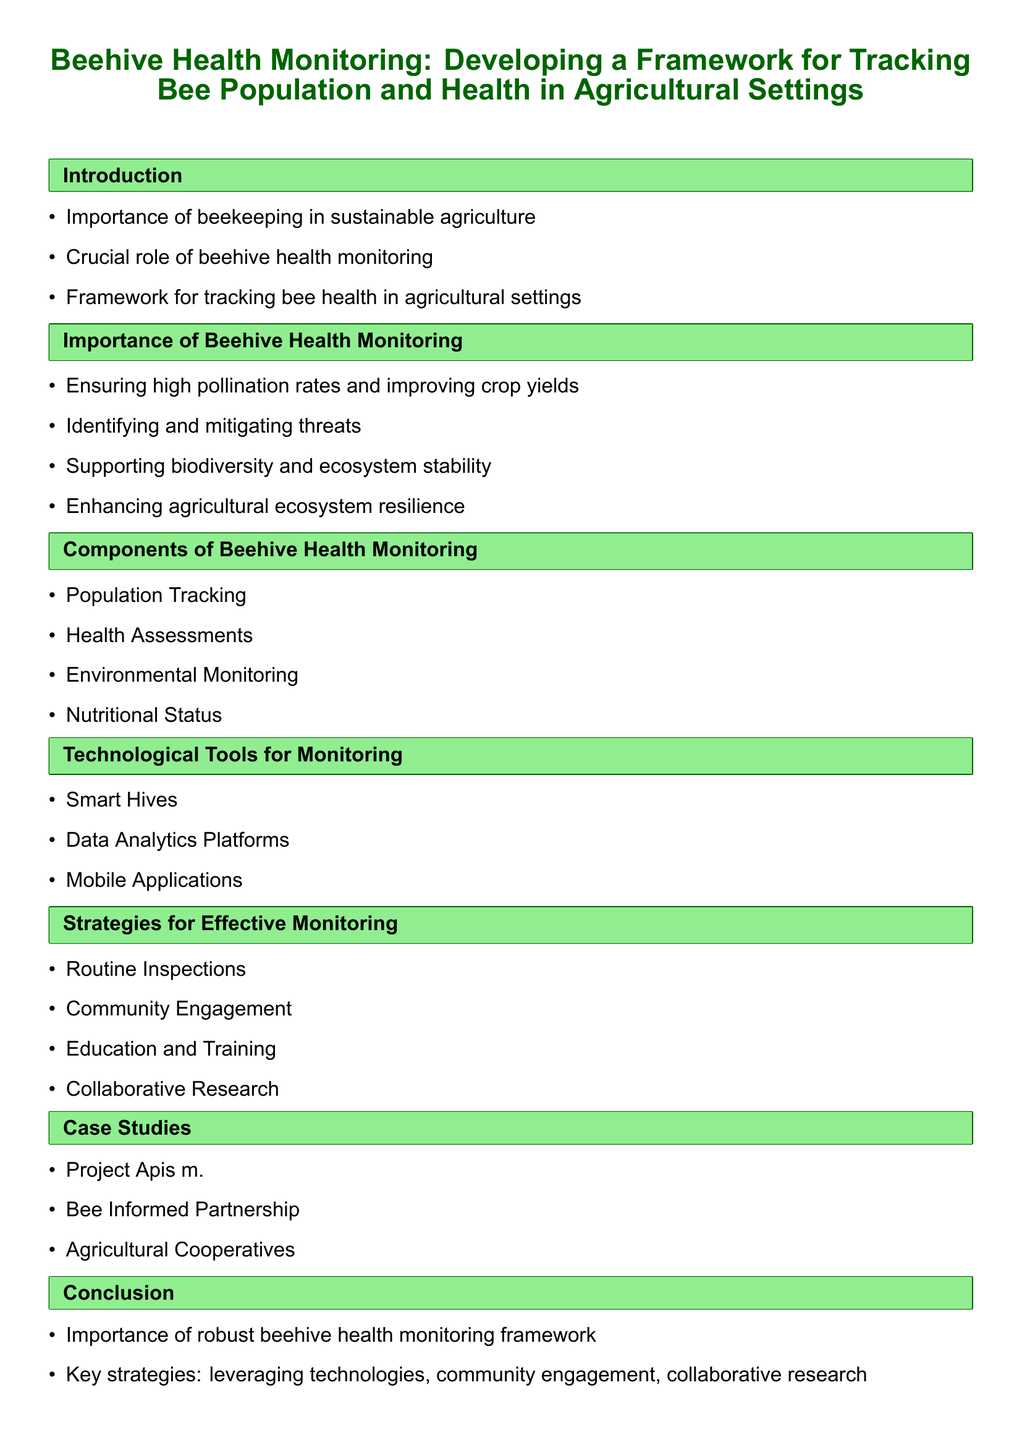What is the title of the document? The title is the main heading displayed prominently in the document.
Answer: Beehive Health Monitoring: Developing a Framework for Tracking Bee Population and Health in Agricultural Settings What is a key benefit of beehive health monitoring? This benefit is mentioned in the importance section, highlighting its impact on agriculture.
Answer: Ensuring high pollination rates and improving crop yields Name one component of beehive health monitoring. The components are listed in their respective section.
Answer: Population Tracking What technological tool is mentioned for monitoring? This tool is listed in the section dedicated to technological tools.
Answer: Smart Hives What strategy is suggested for effective monitoring? The strategies are outlined in their respective section of the document.
Answer: Routine Inspections Which organization is included in the case studies? This organization is one example listed under the case studies section.
Answer: Project Apis m How many strategies for effective monitoring are outlined? This information can be obtained by counting the items in the strategies section.
Answer: Four What color is used for section headings? The color is described in the formatting notes regarding section presentation.
Answer: Dark green What is the main focus of the conclusion? The conclusion summarizes the document's overarching theme and key takeaways.
Answer: Importance of robust beehive health monitoring framework 